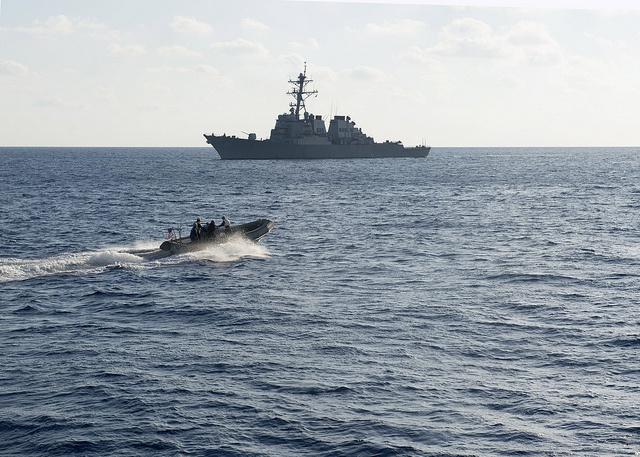Describe the objects in this image and their specific colors. I can see boat in white, gray, darkblue, and lightgray tones, boat in white, gray, black, darkgray, and lightgray tones, people in white, black, gray, darkgray, and darkgreen tones, people in white, black, and gray tones, and people in white, black, gray, and navy tones in this image. 